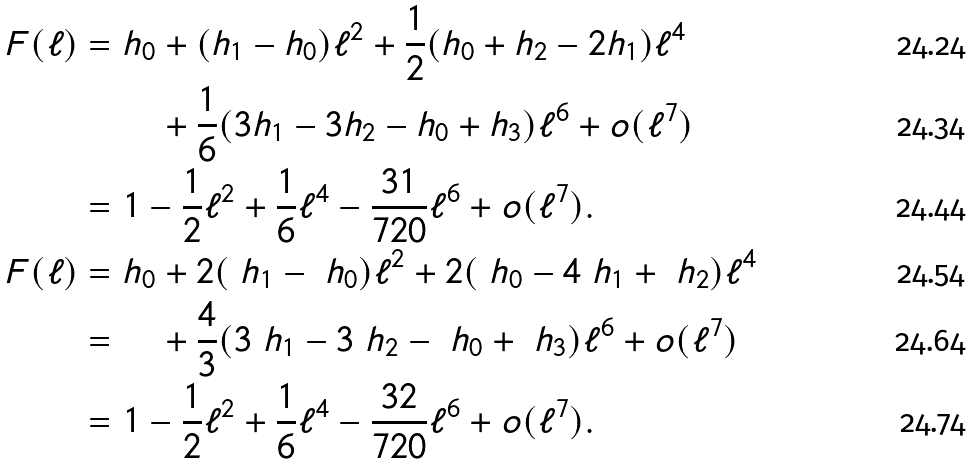<formula> <loc_0><loc_0><loc_500><loc_500>F ( \ell ) = & \ h _ { 0 } + ( h _ { 1 } - h _ { 0 } ) \ell ^ { 2 } + \frac { 1 } { 2 } ( h _ { 0 } + h _ { 2 } - 2 h _ { 1 } ) \ell ^ { 4 } \\ & \ \quad + \frac { 1 } { 6 } ( 3 h _ { 1 } - 3 h _ { 2 } - h _ { 0 } + h _ { 3 } ) \ell ^ { 6 } + o ( \ell ^ { 7 } ) \\ = & \ 1 - \frac { 1 } { 2 } \ell ^ { 2 } + \frac { 1 } { 6 } \ell ^ { 4 } - \frac { 3 1 } { 7 2 0 } \ell ^ { 6 } + o ( \ell ^ { 7 } ) . \\ \ F ( \ell ) = & \ h _ { 0 } + 2 ( \ h _ { 1 } - \ h _ { 0 } ) \ell ^ { 2 } + 2 ( \ h _ { 0 } - 4 \ h _ { 1 } + \ h _ { 2 } ) \ell ^ { 4 } \\ = & \ \quad + \frac { 4 } { 3 } ( 3 \ h _ { 1 } - 3 \ h _ { 2 } - \ h _ { 0 } + \ h _ { 3 } ) \ell ^ { 6 } + o ( \ell ^ { 7 } ) \\ = & \ 1 - \frac { 1 } { 2 } \ell ^ { 2 } + \frac { 1 } { 6 } \ell ^ { 4 } - \frac { 3 2 } { 7 2 0 } \ell ^ { 6 } + o ( \ell ^ { 7 } ) .</formula> 